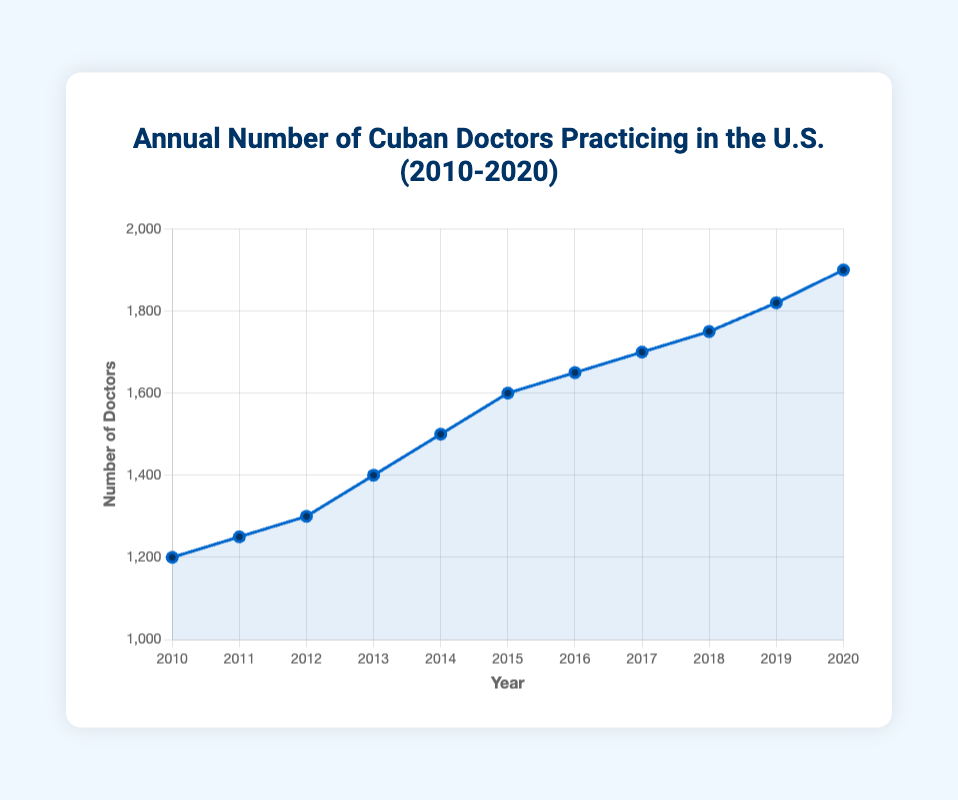How many more Cuban doctors were practicing in the U.S. in 2020 compared to 2010? Find the number of doctors in 2020 (1900) and in 2010 (1200). Subtract the 2010 number from the 2020 number: 1900 - 1200 = 700
Answer: 700 Which year saw the largest increase in the number of Cuban doctors compared to the previous year? Calculate the difference for each year and find the maximum. The differences are: 2011-2010: 50, 2012-2011: 50, 2013-2012: 100, 2014-2013: 100, 2015-2014: 100, 2016-2015: 50, 2017-2016: 50, 2018-2017: 50, 2019-2018: 70, 2020-2019: 80. The maximum increase was 100 in 2013, 2014, and 2015.
Answer: 2013, 2014, 2015 What is the average annual increase in the number of Cuban doctors from 2010 to 2020? The total increase over 10 years is 1900 - 1200 = 700. The average annual increase is 700 / 10 = 70
Answer: 70 In which year did the number of Cuban doctors first exceed 1500? Look at the data for each year and find the first year where the number is greater than 1500. It is 2015, when the number of doctors was 1600.
Answer: 2015 By how much did the number of Cuban doctors increase from 2015 to 2018? Find the number of doctors in 2015 (1600) and in 2018 (1750). Subtract the 2015 number from the 2018 number: 1750 - 1600 = 150
Answer: 150 How long did it take for the number of Cuban doctors to increase by 500, starting in 2010? Starting at 1200 in 2010, the number reached 1700 in 2017. The time taken is 2017 - 2010 = 7 years
Answer: 7 years What was the total number of Cuban doctors practicing in the U.S. at the end of 2015 and 2020 combined? Add the number of doctors in 2015 (1600) and in 2020 (1900). 1600 + 1900 = 3500
Answer: 3500 